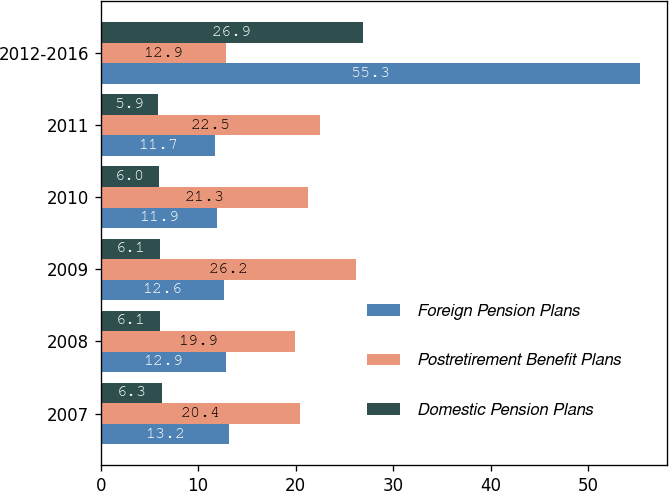Convert chart to OTSL. <chart><loc_0><loc_0><loc_500><loc_500><stacked_bar_chart><ecel><fcel>2007<fcel>2008<fcel>2009<fcel>2010<fcel>2011<fcel>2012-2016<nl><fcel>Foreign Pension Plans<fcel>13.2<fcel>12.9<fcel>12.6<fcel>11.9<fcel>11.7<fcel>55.3<nl><fcel>Postretirement Benefit Plans<fcel>20.4<fcel>19.9<fcel>26.2<fcel>21.3<fcel>22.5<fcel>12.9<nl><fcel>Domestic Pension Plans<fcel>6.3<fcel>6.1<fcel>6.1<fcel>6<fcel>5.9<fcel>26.9<nl></chart> 